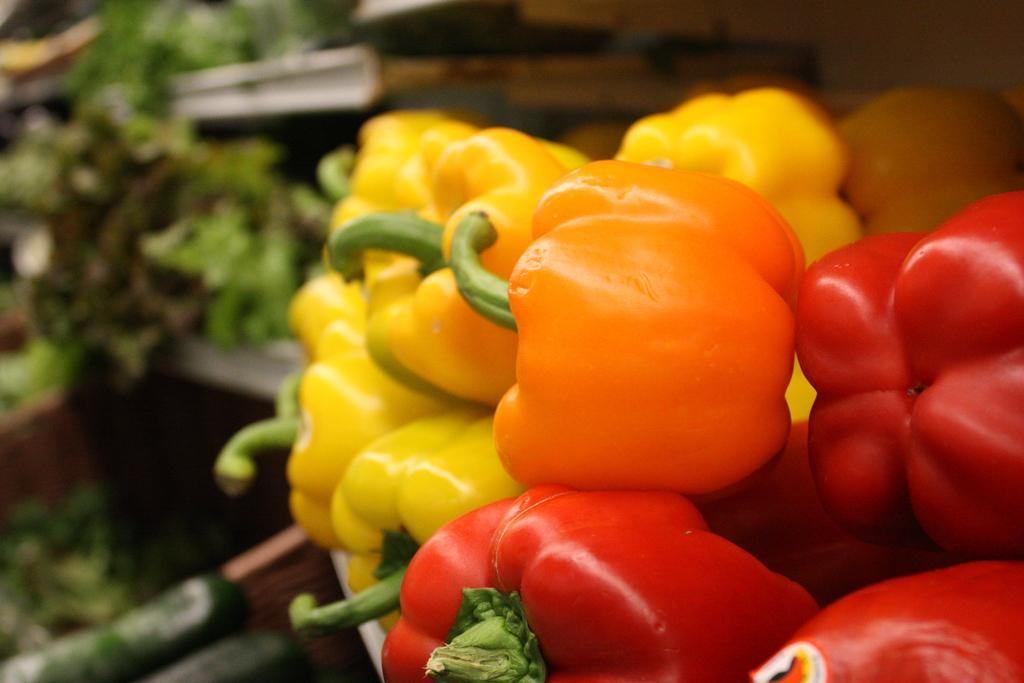What types of capsicums are in the foreground of the image? There are yellow, orange, and red capsicums in the foreground of the image. What category of food do these capsicums belong to? These capsicums are vegetables. What other vegetables can be seen in the image? There are leafy vegetables in the background of the image. Where are the leafy vegetables located? The leafy vegetables are on a table. What type of powder is being used to insure the vegetables in the image? There is no powder or insurance mentioned in the image; it simply shows capsicums and leafy vegetables. 